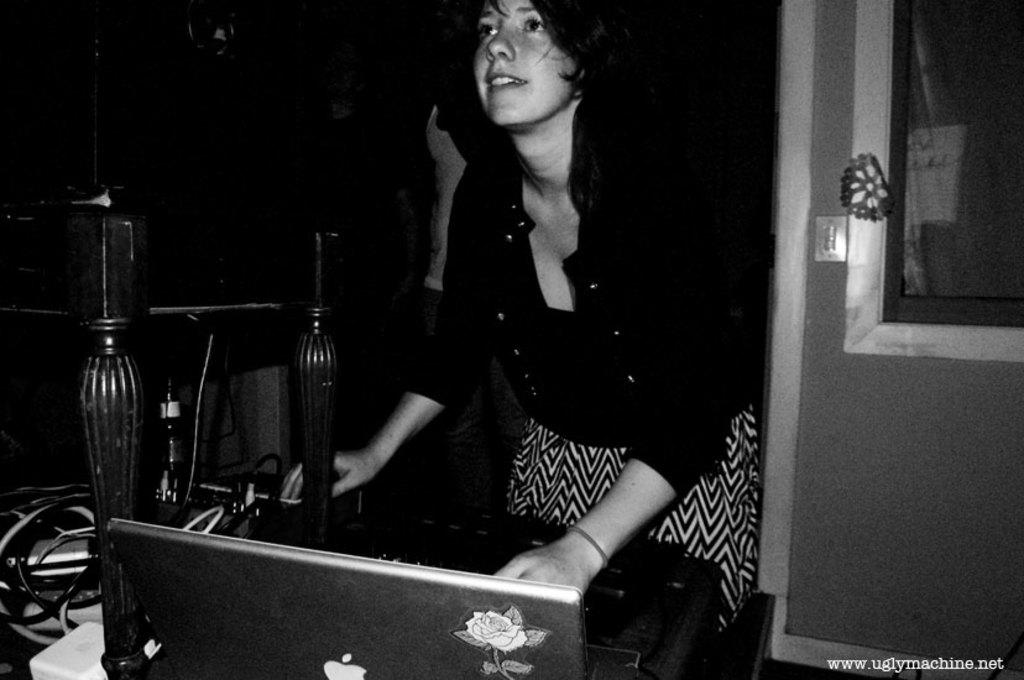What is the color scheme of the image? The image is black and white. Who is present in the image? There is a lady standing in the image. What object is in front of the lady? There is a table in front of the lady. What is on the table? There is a laptop on the table. Where can we find additional information or text in the image? There is text in the bottom right corner of the image. What type of powder is being used by the lady in the image? There is no powder visible in the image, and the lady is not performing any activity that would involve using powder. 